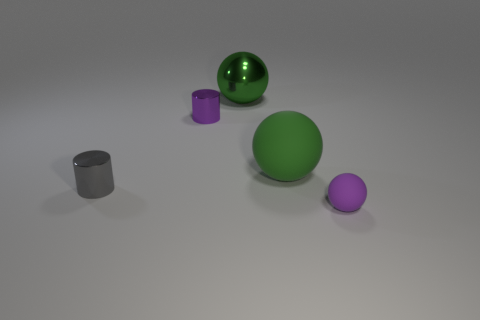What number of small purple things are the same material as the purple ball?
Provide a succinct answer. 0. Are there fewer tiny purple matte balls than small objects?
Ensure brevity in your answer.  Yes. What is the size of the other thing that is the same shape as the purple metal object?
Your response must be concise. Small. Are the purple object behind the small purple matte thing and the gray cylinder made of the same material?
Offer a terse response. Yes. Do the purple rubber thing and the green metal thing have the same shape?
Make the answer very short. Yes. How many objects are either rubber things to the left of the purple rubber thing or purple matte things?
Your answer should be compact. 2. What size is the green thing that is the same material as the tiny gray cylinder?
Provide a short and direct response. Large. How many metallic objects have the same color as the tiny ball?
Ensure brevity in your answer.  1. What number of big things are either green metal objects or cylinders?
Provide a succinct answer. 1. There is a metallic object that is the same color as the large rubber sphere; what size is it?
Ensure brevity in your answer.  Large. 